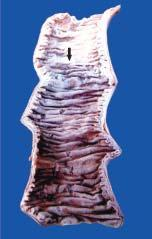does a sharp line of demarcation separate infarcted area from the normal bowel?
Answer the question using a single word or phrase. Yes 